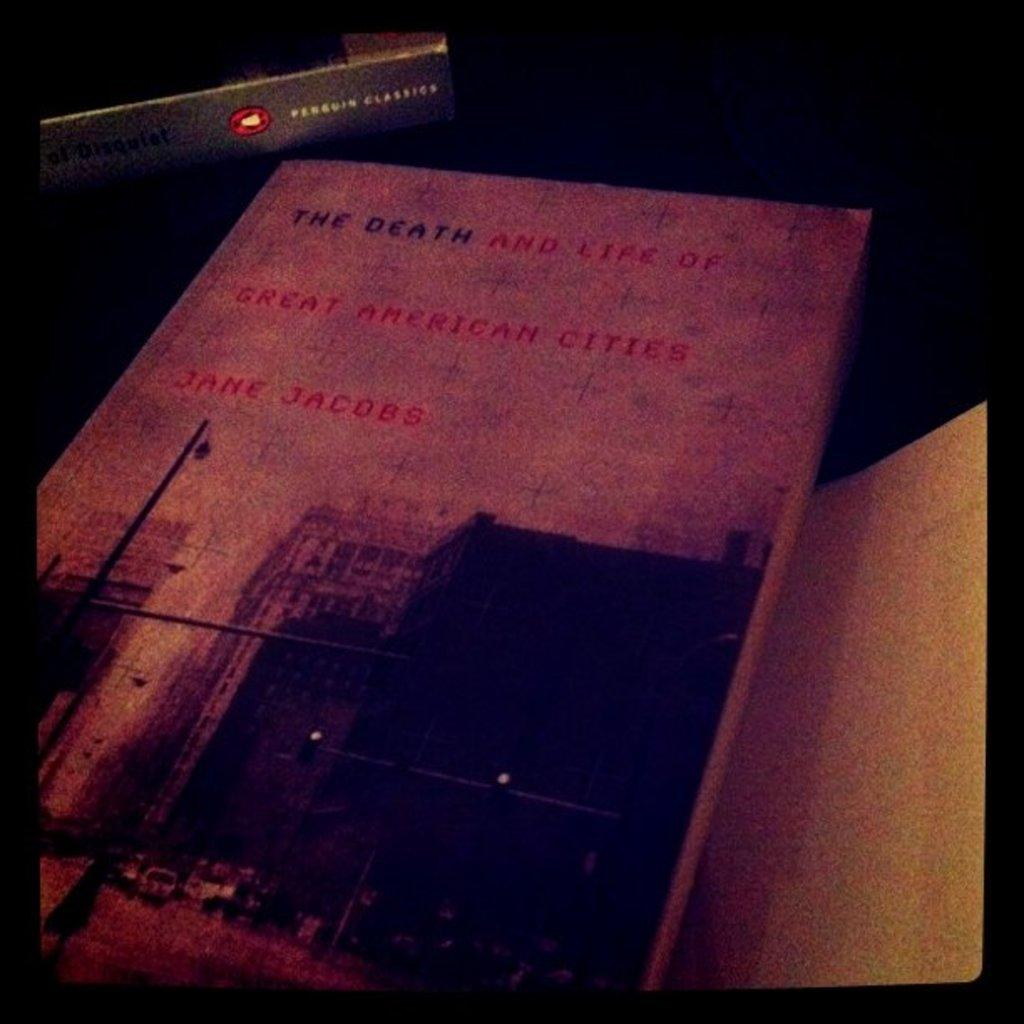<image>
Summarize the visual content of the image. Jane Jacobs wrote The Death and life of Great American Cities, which shows a shadowy city on the cover. 